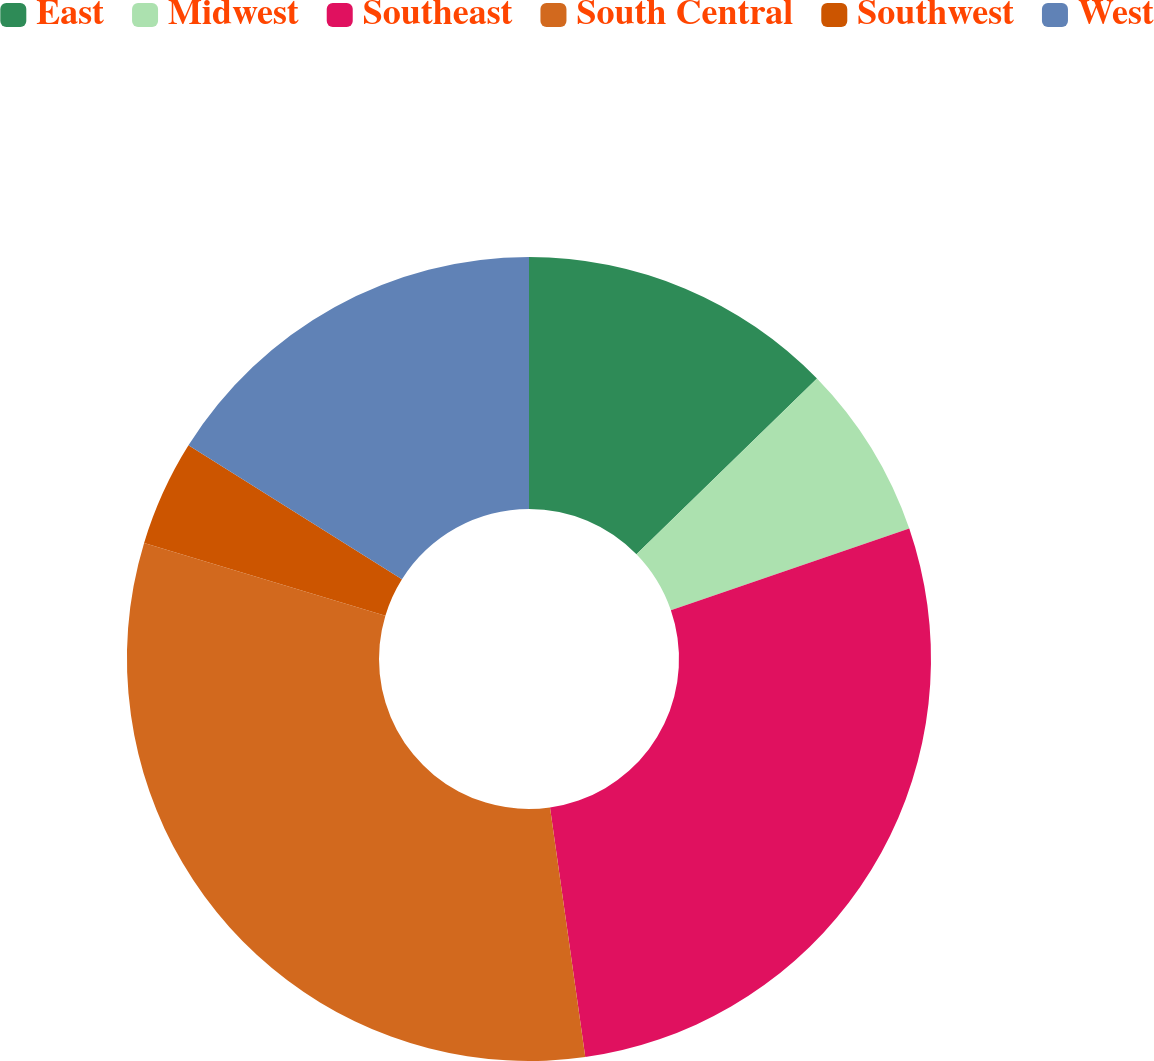<chart> <loc_0><loc_0><loc_500><loc_500><pie_chart><fcel>East<fcel>Midwest<fcel>Southeast<fcel>South Central<fcel>Southwest<fcel>West<nl><fcel>12.71%<fcel>7.03%<fcel>28.02%<fcel>31.89%<fcel>4.26%<fcel>16.08%<nl></chart> 